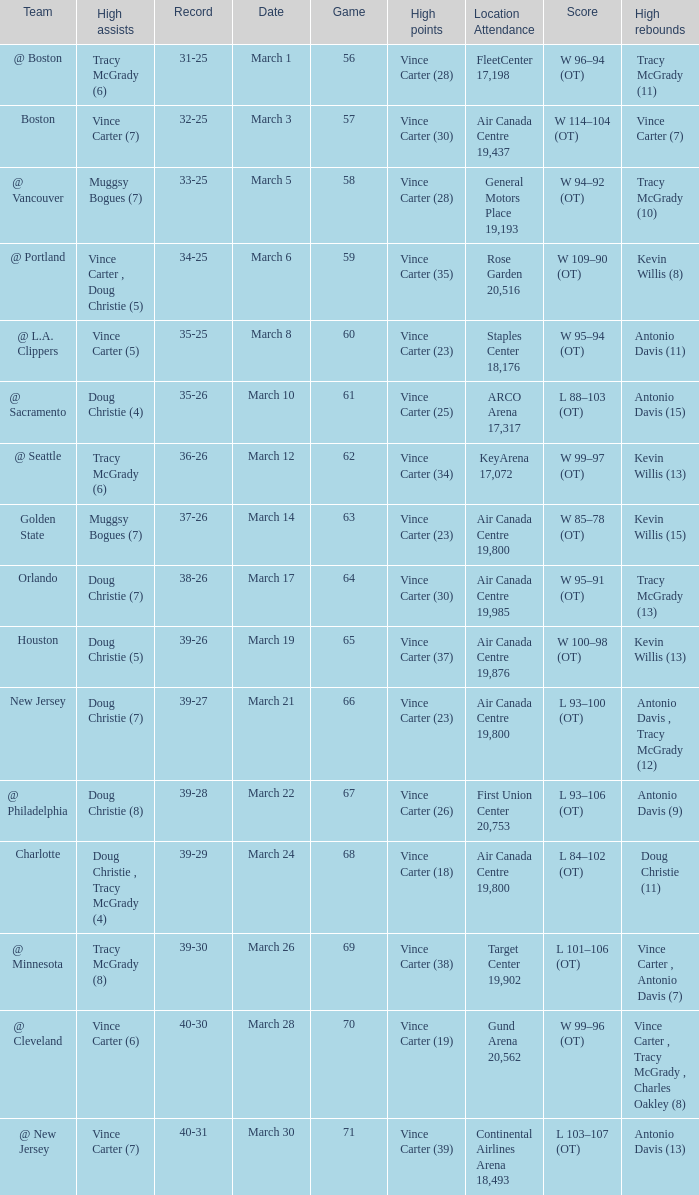What day was the attendance at the staples center 18,176? March 8. 